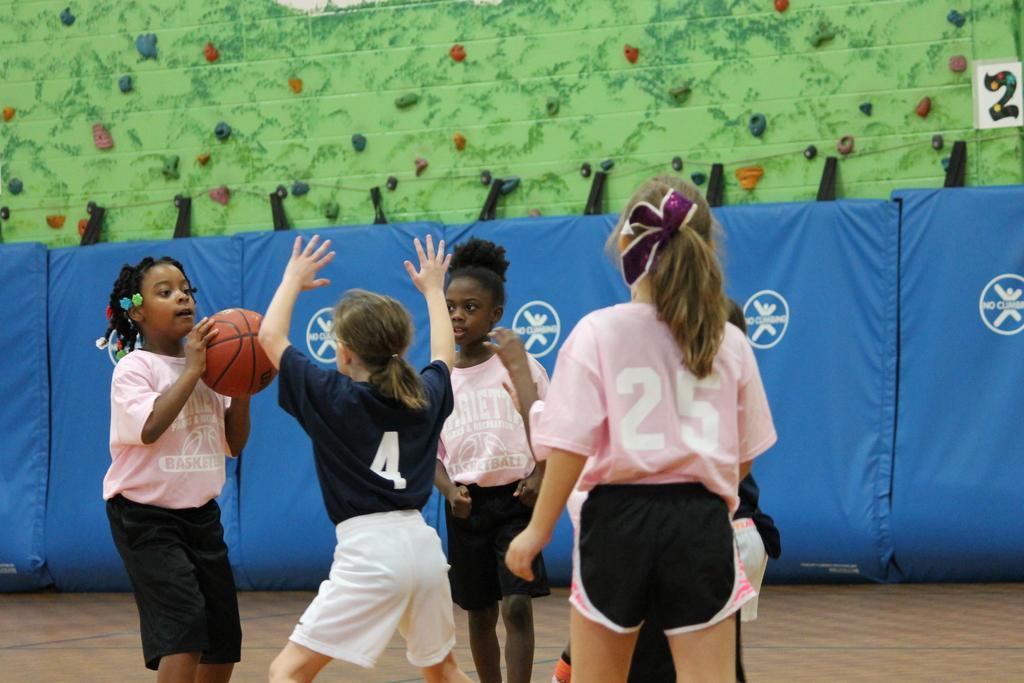In one or two sentences, can you explain what this image depicts? In this picture we can see people on the ground and one girl is holding a ball and in the background we can see curtains and some objects. 